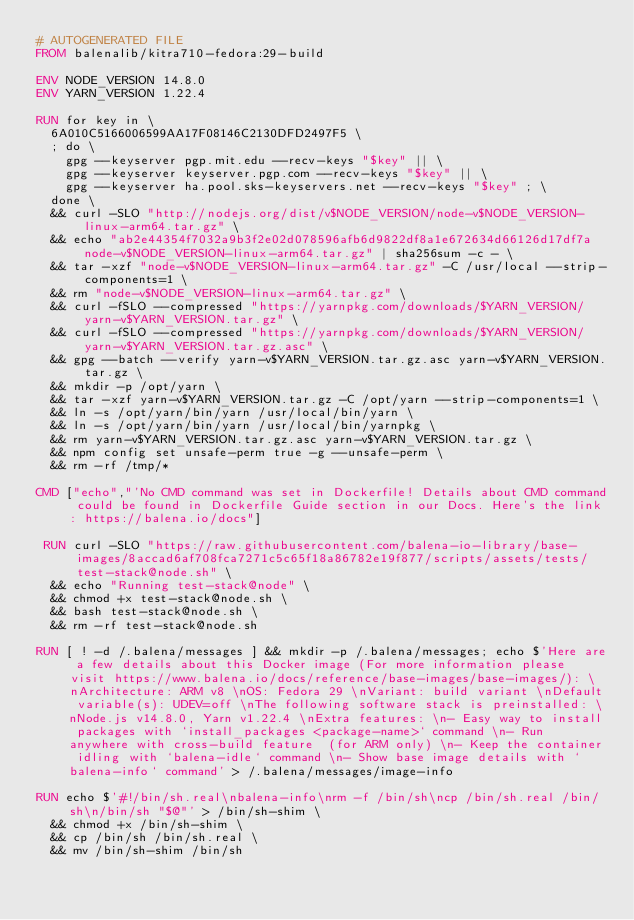Convert code to text. <code><loc_0><loc_0><loc_500><loc_500><_Dockerfile_># AUTOGENERATED FILE
FROM balenalib/kitra710-fedora:29-build

ENV NODE_VERSION 14.8.0
ENV YARN_VERSION 1.22.4

RUN for key in \
	6A010C5166006599AA17F08146C2130DFD2497F5 \
	; do \
		gpg --keyserver pgp.mit.edu --recv-keys "$key" || \
		gpg --keyserver keyserver.pgp.com --recv-keys "$key" || \
		gpg --keyserver ha.pool.sks-keyservers.net --recv-keys "$key" ; \
	done \
	&& curl -SLO "http://nodejs.org/dist/v$NODE_VERSION/node-v$NODE_VERSION-linux-arm64.tar.gz" \
	&& echo "ab2e44354f7032a9b3f2e02d078596afb6d9822df8a1e672634d66126d17df7a  node-v$NODE_VERSION-linux-arm64.tar.gz" | sha256sum -c - \
	&& tar -xzf "node-v$NODE_VERSION-linux-arm64.tar.gz" -C /usr/local --strip-components=1 \
	&& rm "node-v$NODE_VERSION-linux-arm64.tar.gz" \
	&& curl -fSLO --compressed "https://yarnpkg.com/downloads/$YARN_VERSION/yarn-v$YARN_VERSION.tar.gz" \
	&& curl -fSLO --compressed "https://yarnpkg.com/downloads/$YARN_VERSION/yarn-v$YARN_VERSION.tar.gz.asc" \
	&& gpg --batch --verify yarn-v$YARN_VERSION.tar.gz.asc yarn-v$YARN_VERSION.tar.gz \
	&& mkdir -p /opt/yarn \
	&& tar -xzf yarn-v$YARN_VERSION.tar.gz -C /opt/yarn --strip-components=1 \
	&& ln -s /opt/yarn/bin/yarn /usr/local/bin/yarn \
	&& ln -s /opt/yarn/bin/yarn /usr/local/bin/yarnpkg \
	&& rm yarn-v$YARN_VERSION.tar.gz.asc yarn-v$YARN_VERSION.tar.gz \
	&& npm config set unsafe-perm true -g --unsafe-perm \
	&& rm -rf /tmp/*

CMD ["echo","'No CMD command was set in Dockerfile! Details about CMD command could be found in Dockerfile Guide section in our Docs. Here's the link: https://balena.io/docs"]

 RUN curl -SLO "https://raw.githubusercontent.com/balena-io-library/base-images/8accad6af708fca7271c5c65f18a86782e19f877/scripts/assets/tests/test-stack@node.sh" \
  && echo "Running test-stack@node" \
  && chmod +x test-stack@node.sh \
  && bash test-stack@node.sh \
  && rm -rf test-stack@node.sh 

RUN [ ! -d /.balena/messages ] && mkdir -p /.balena/messages; echo $'Here are a few details about this Docker image (For more information please visit https://www.balena.io/docs/reference/base-images/base-images/): \nArchitecture: ARM v8 \nOS: Fedora 29 \nVariant: build variant \nDefault variable(s): UDEV=off \nThe following software stack is preinstalled: \nNode.js v14.8.0, Yarn v1.22.4 \nExtra features: \n- Easy way to install packages with `install_packages <package-name>` command \n- Run anywhere with cross-build feature  (for ARM only) \n- Keep the container idling with `balena-idle` command \n- Show base image details with `balena-info` command' > /.balena/messages/image-info

RUN echo $'#!/bin/sh.real\nbalena-info\nrm -f /bin/sh\ncp /bin/sh.real /bin/sh\n/bin/sh "$@"' > /bin/sh-shim \
	&& chmod +x /bin/sh-shim \
	&& cp /bin/sh /bin/sh.real \
	&& mv /bin/sh-shim /bin/sh</code> 